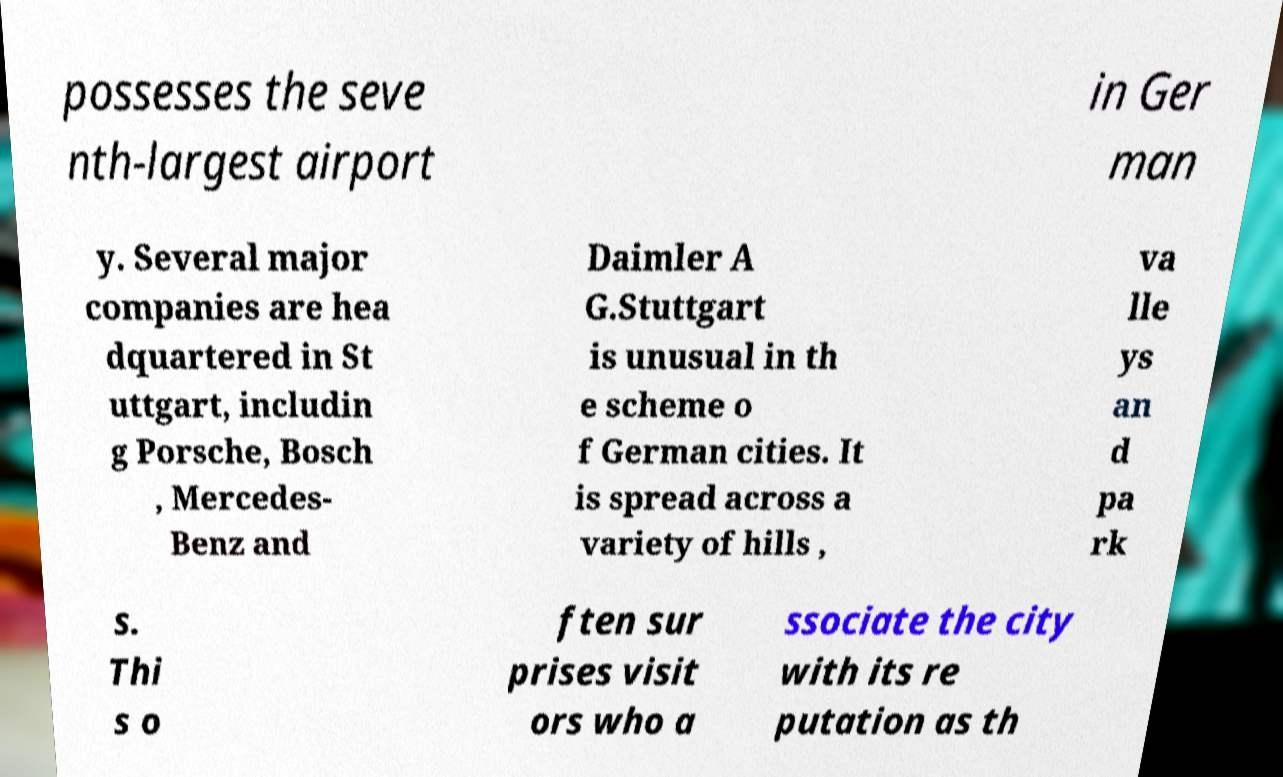Could you assist in decoding the text presented in this image and type it out clearly? possesses the seve nth-largest airport in Ger man y. Several major companies are hea dquartered in St uttgart, includin g Porsche, Bosch , Mercedes- Benz and Daimler A G.Stuttgart is unusual in th e scheme o f German cities. It is spread across a variety of hills , va lle ys an d pa rk s. Thi s o ften sur prises visit ors who a ssociate the city with its re putation as th 